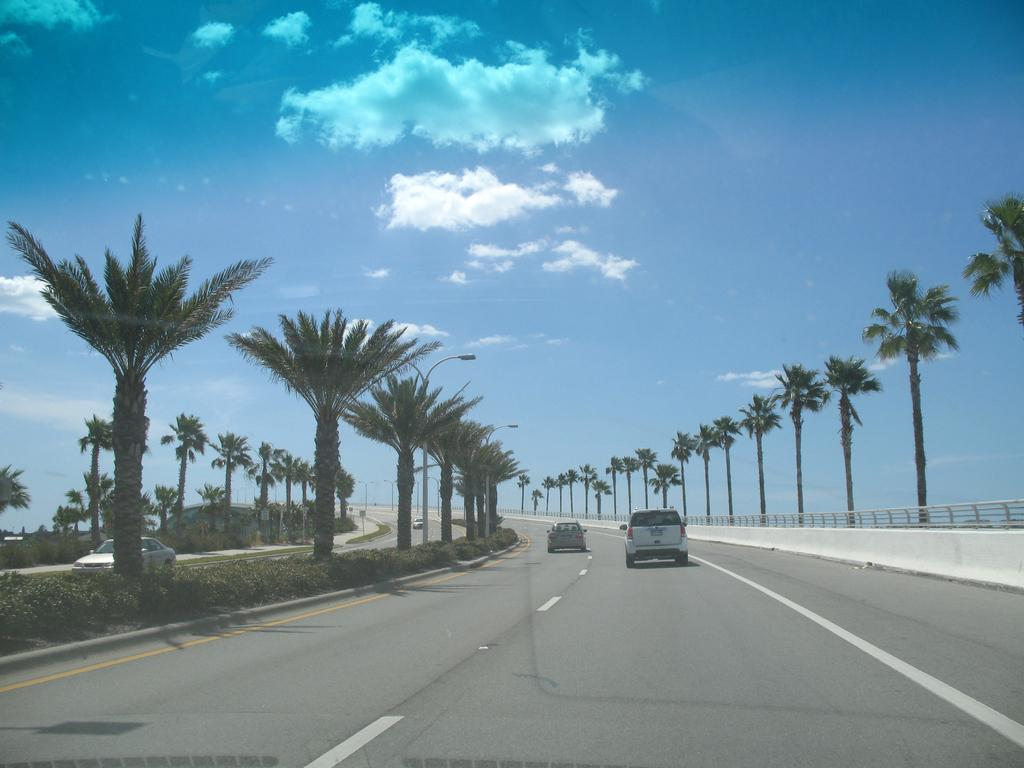What can be seen on the road in the image? There are cars on the road in the image. What type of vegetation is present beside the cars? Shrubs are present beside the cars. What other natural elements can be seen in the image? There are trees in the image. What man-made structures are visible in the image? Poles and a fence are visible in the image. What is visible in the background of the image? Clouds are present in the background of the image. What type of brass instrument is being played by the team in the image? There is no brass instrument or team present in the image. How does the fence slip in the image? The fence does not slip in the image; it is stationary and secure. 